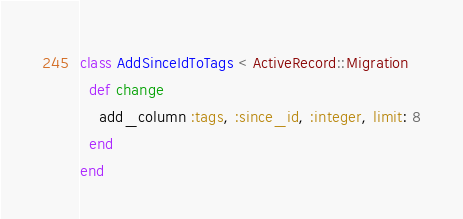<code> <loc_0><loc_0><loc_500><loc_500><_Ruby_>class AddSinceIdToTags < ActiveRecord::Migration
  def change
    add_column :tags, :since_id, :integer, limit: 8
  end
end
</code> 